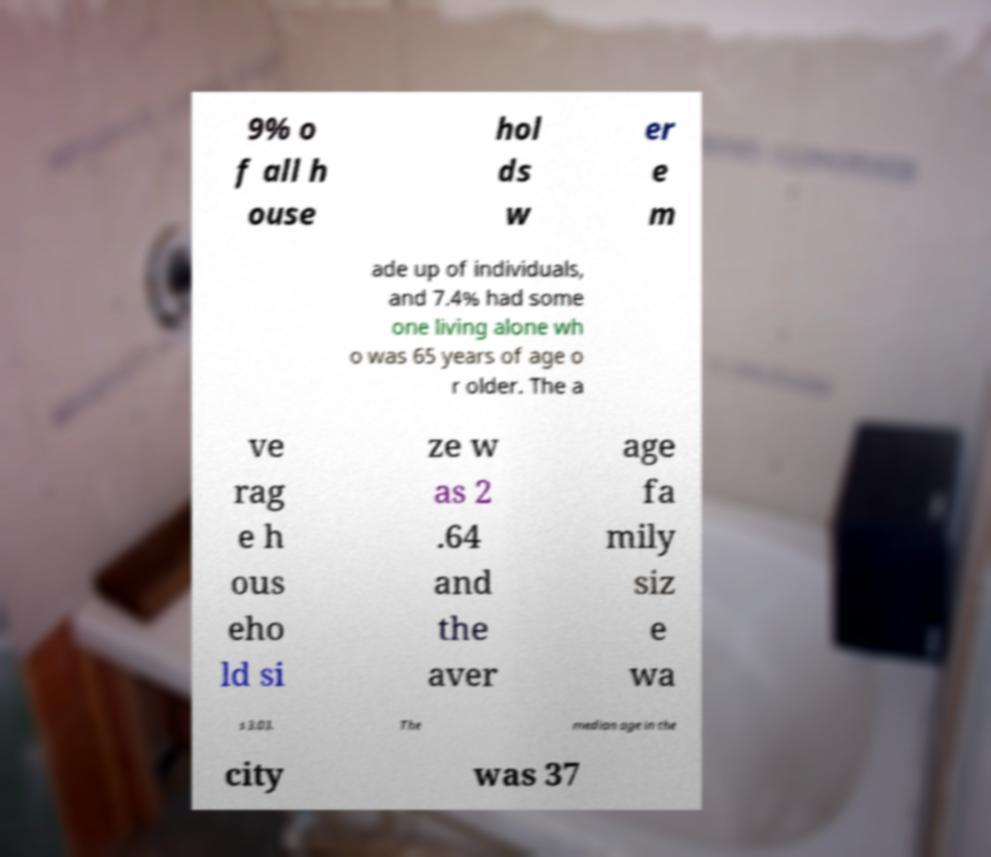Please read and relay the text visible in this image. What does it say? 9% o f all h ouse hol ds w er e m ade up of individuals, and 7.4% had some one living alone wh o was 65 years of age o r older. The a ve rag e h ous eho ld si ze w as 2 .64 and the aver age fa mily siz e wa s 3.03. The median age in the city was 37 